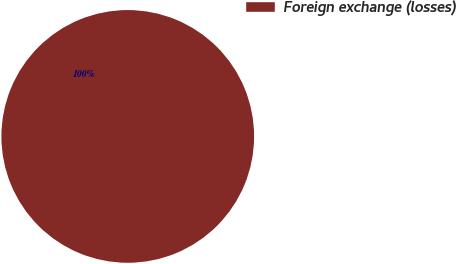Convert chart to OTSL. <chart><loc_0><loc_0><loc_500><loc_500><pie_chart><fcel>Foreign exchange (losses)<nl><fcel>100.0%<nl></chart> 